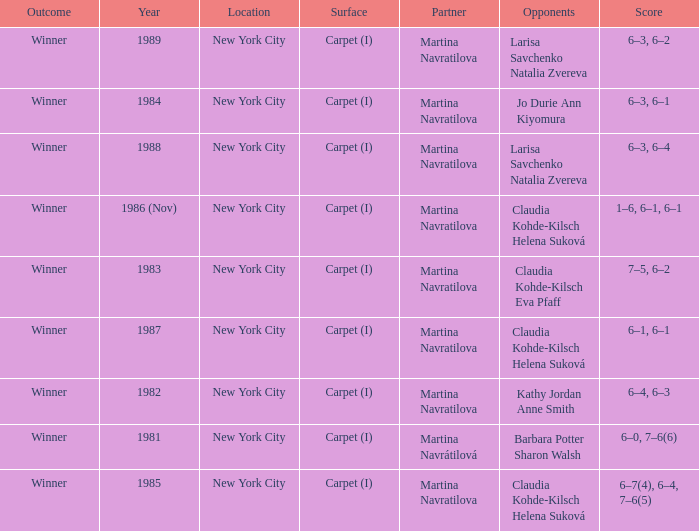How many locations hosted Claudia Kohde-Kilsch Eva Pfaff? 1.0. 